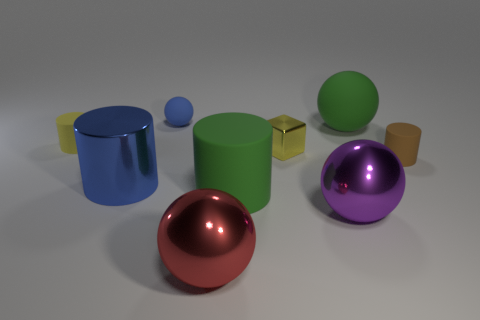Subtract all gray cylinders. Subtract all gray spheres. How many cylinders are left? 4 Add 1 tiny green cubes. How many objects exist? 10 Subtract all cylinders. How many objects are left? 5 Subtract 1 green cylinders. How many objects are left? 8 Subtract all metal cylinders. Subtract all small matte balls. How many objects are left? 7 Add 6 large matte balls. How many large matte balls are left? 7 Add 5 tiny rubber balls. How many tiny rubber balls exist? 6 